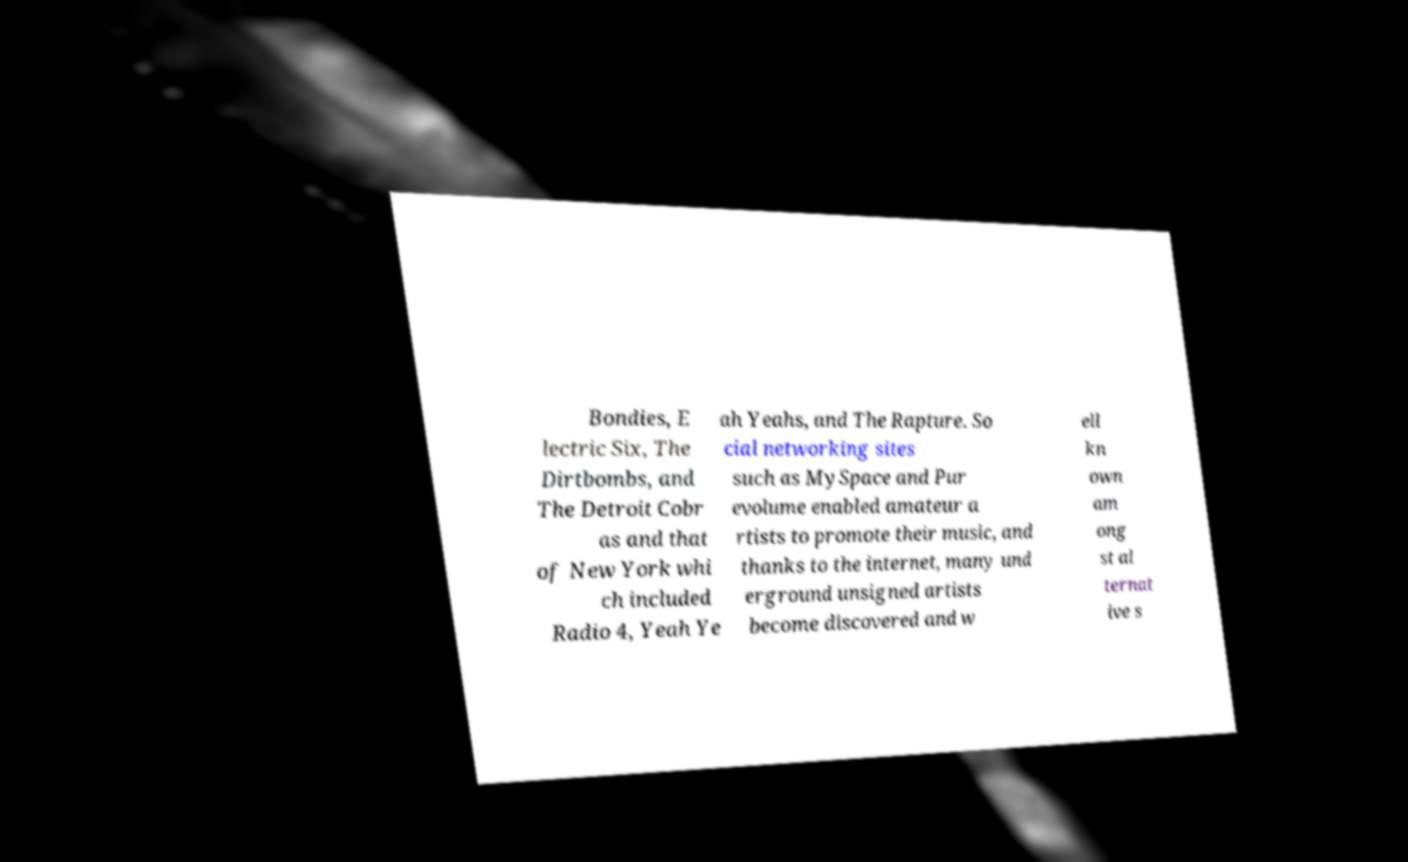Could you extract and type out the text from this image? Bondies, E lectric Six, The Dirtbombs, and The Detroit Cobr as and that of New York whi ch included Radio 4, Yeah Ye ah Yeahs, and The Rapture. So cial networking sites such as MySpace and Pur evolume enabled amateur a rtists to promote their music, and thanks to the internet, many und erground unsigned artists become discovered and w ell kn own am ong st al ternat ive s 